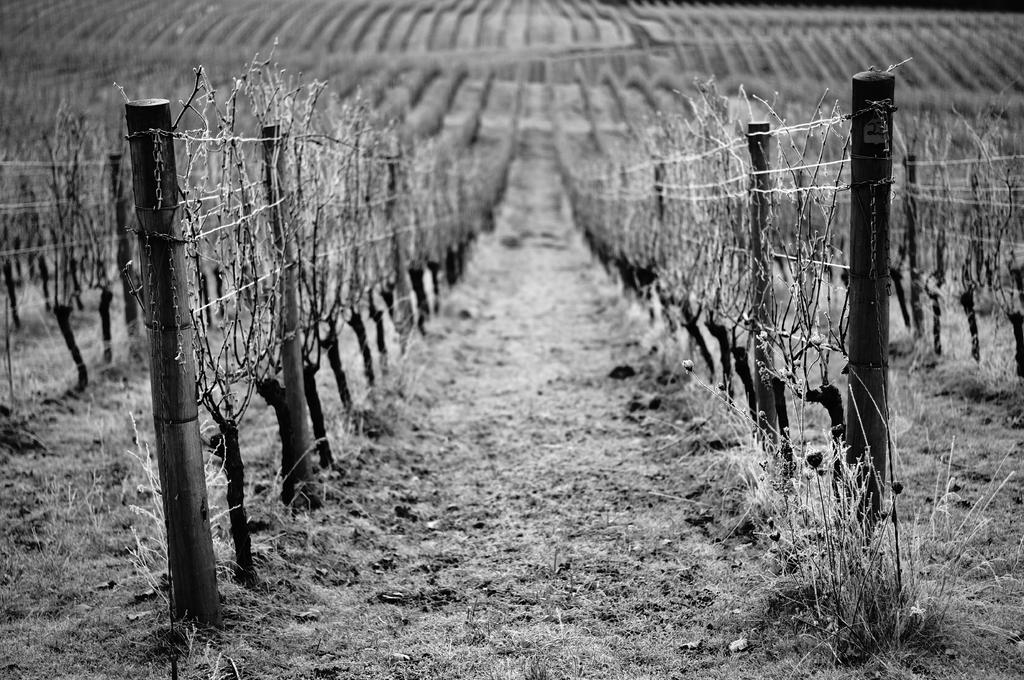What type of structure can be seen in the image? There is fencing present in the image. How does the fencing appear in relation to the ground? The fencing covers the ground. What else can be found within the fencing? Plants are present within the fencing. Are there any fairies visible within the fencing in the image? There are no fairies present in the image; only fencing and plants can be seen. 